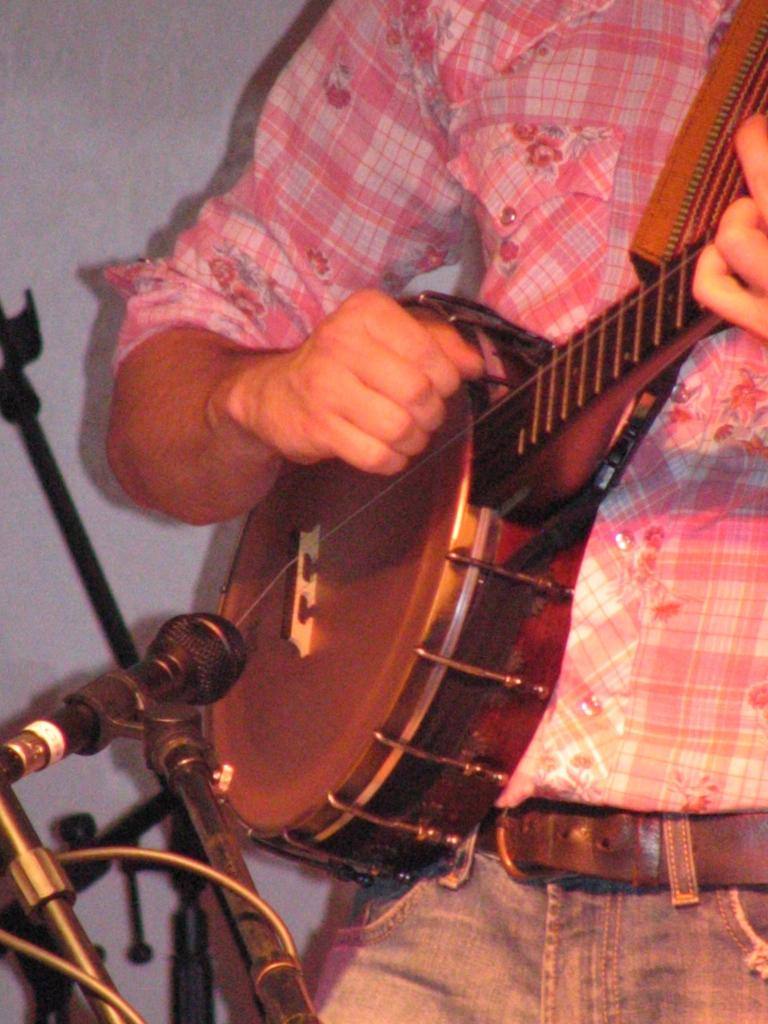What part of a person can be seen in the image? There is a hand of a person in the image. What object related to music is present in the image? There is a musical instrument in the image. What device is used for amplifying sound in the image? There is a microphone (mic) in front of the musical instrument in the image. Can you see a gun in the image? No, there is no gun present in the image. Is there a scarecrow playing the musical instrument in the image? No, there is no scarecrow in the image; it is a hand of a person playing the musical instrument. 